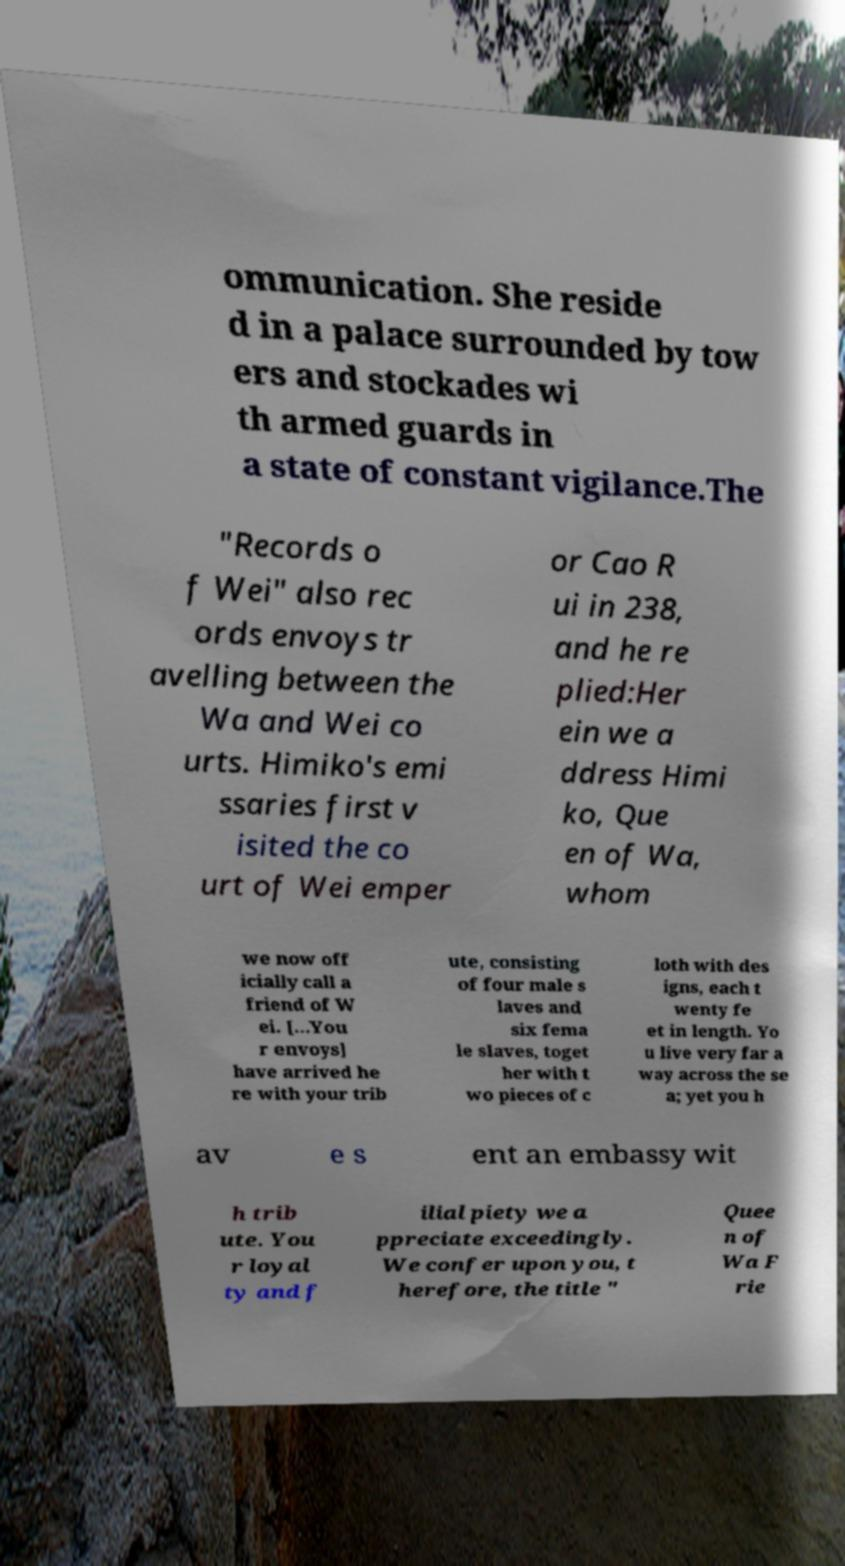Can you read and provide the text displayed in the image?This photo seems to have some interesting text. Can you extract and type it out for me? ommunication. She reside d in a palace surrounded by tow ers and stockades wi th armed guards in a state of constant vigilance.The "Records o f Wei" also rec ords envoys tr avelling between the Wa and Wei co urts. Himiko's emi ssaries first v isited the co urt of Wei emper or Cao R ui in 238, and he re plied:Her ein we a ddress Himi ko, Que en of Wa, whom we now off icially call a friend of W ei. […You r envoys] have arrived he re with your trib ute, consisting of four male s laves and six fema le slaves, toget her with t wo pieces of c loth with des igns, each t wenty fe et in length. Yo u live very far a way across the se a; yet you h av e s ent an embassy wit h trib ute. You r loyal ty and f ilial piety we a ppreciate exceedingly. We confer upon you, t herefore, the title " Quee n of Wa F rie 